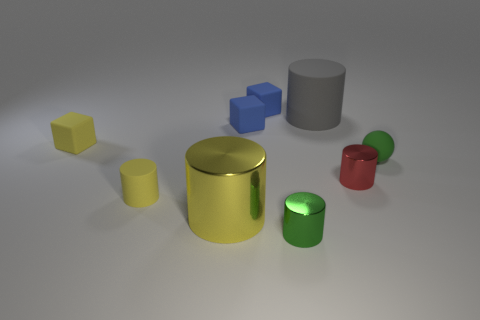What do you think is the purpose of this collection of cylinders? The collection of cylinders in the image might serve an educational purpose, such as teaching about geometry, colors, and relative sizes in a school setting, or they could be simply decorative, highlighting how objects with similar shapes but different sizes can create an aesthetic arrangement. 